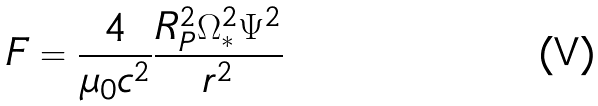Convert formula to latex. <formula><loc_0><loc_0><loc_500><loc_500>F = \frac { 4 } { \mu _ { 0 } c ^ { 2 } } \frac { R _ { P } ^ { 2 } \Omega _ { * } ^ { 2 } \Psi ^ { 2 } } { r ^ { 2 } }</formula> 